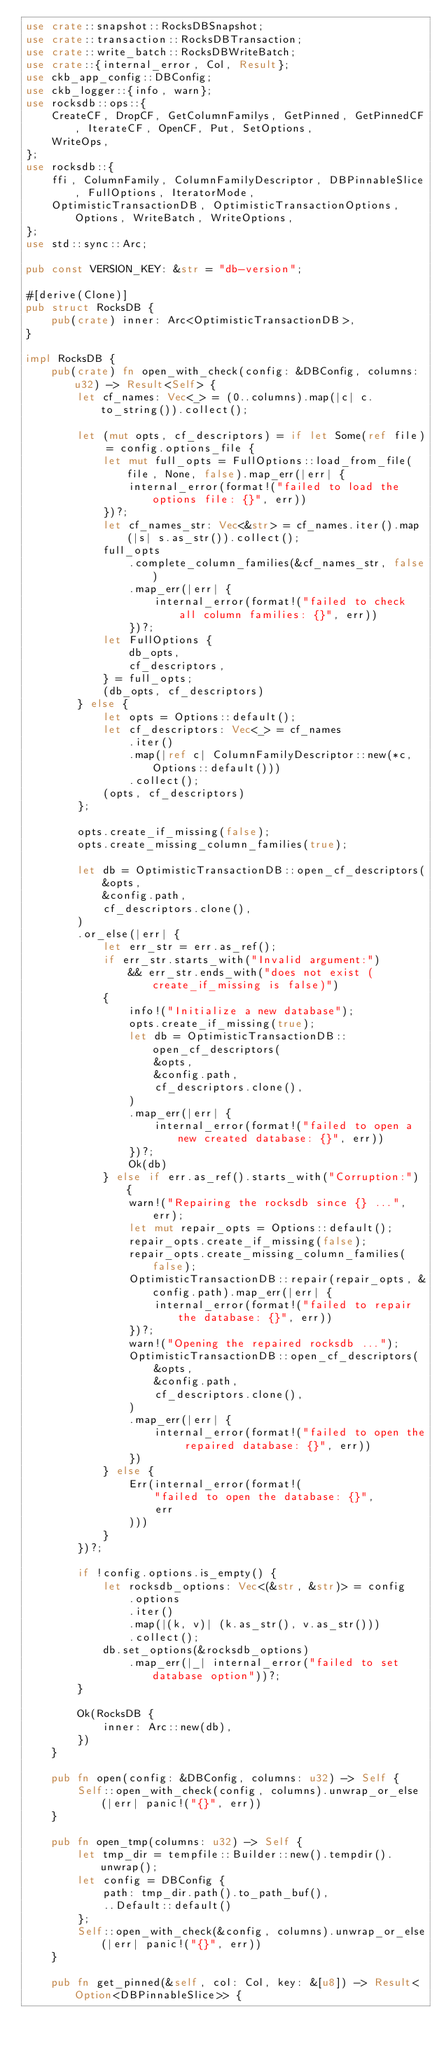<code> <loc_0><loc_0><loc_500><loc_500><_Rust_>use crate::snapshot::RocksDBSnapshot;
use crate::transaction::RocksDBTransaction;
use crate::write_batch::RocksDBWriteBatch;
use crate::{internal_error, Col, Result};
use ckb_app_config::DBConfig;
use ckb_logger::{info, warn};
use rocksdb::ops::{
    CreateCF, DropCF, GetColumnFamilys, GetPinned, GetPinnedCF, IterateCF, OpenCF, Put, SetOptions,
    WriteOps,
};
use rocksdb::{
    ffi, ColumnFamily, ColumnFamilyDescriptor, DBPinnableSlice, FullOptions, IteratorMode,
    OptimisticTransactionDB, OptimisticTransactionOptions, Options, WriteBatch, WriteOptions,
};
use std::sync::Arc;

pub const VERSION_KEY: &str = "db-version";

#[derive(Clone)]
pub struct RocksDB {
    pub(crate) inner: Arc<OptimisticTransactionDB>,
}

impl RocksDB {
    pub(crate) fn open_with_check(config: &DBConfig, columns: u32) -> Result<Self> {
        let cf_names: Vec<_> = (0..columns).map(|c| c.to_string()).collect();

        let (mut opts, cf_descriptors) = if let Some(ref file) = config.options_file {
            let mut full_opts = FullOptions::load_from_file(file, None, false).map_err(|err| {
                internal_error(format!("failed to load the options file: {}", err))
            })?;
            let cf_names_str: Vec<&str> = cf_names.iter().map(|s| s.as_str()).collect();
            full_opts
                .complete_column_families(&cf_names_str, false)
                .map_err(|err| {
                    internal_error(format!("failed to check all column families: {}", err))
                })?;
            let FullOptions {
                db_opts,
                cf_descriptors,
            } = full_opts;
            (db_opts, cf_descriptors)
        } else {
            let opts = Options::default();
            let cf_descriptors: Vec<_> = cf_names
                .iter()
                .map(|ref c| ColumnFamilyDescriptor::new(*c, Options::default()))
                .collect();
            (opts, cf_descriptors)
        };

        opts.create_if_missing(false);
        opts.create_missing_column_families(true);

        let db = OptimisticTransactionDB::open_cf_descriptors(
            &opts,
            &config.path,
            cf_descriptors.clone(),
        )
        .or_else(|err| {
            let err_str = err.as_ref();
            if err_str.starts_with("Invalid argument:")
                && err_str.ends_with("does not exist (create_if_missing is false)")
            {
                info!("Initialize a new database");
                opts.create_if_missing(true);
                let db = OptimisticTransactionDB::open_cf_descriptors(
                    &opts,
                    &config.path,
                    cf_descriptors.clone(),
                )
                .map_err(|err| {
                    internal_error(format!("failed to open a new created database: {}", err))
                })?;
                Ok(db)
            } else if err.as_ref().starts_with("Corruption:") {
                warn!("Repairing the rocksdb since {} ...", err);
                let mut repair_opts = Options::default();
                repair_opts.create_if_missing(false);
                repair_opts.create_missing_column_families(false);
                OptimisticTransactionDB::repair(repair_opts, &config.path).map_err(|err| {
                    internal_error(format!("failed to repair the database: {}", err))
                })?;
                warn!("Opening the repaired rocksdb ...");
                OptimisticTransactionDB::open_cf_descriptors(
                    &opts,
                    &config.path,
                    cf_descriptors.clone(),
                )
                .map_err(|err| {
                    internal_error(format!("failed to open the repaired database: {}", err))
                })
            } else {
                Err(internal_error(format!(
                    "failed to open the database: {}",
                    err
                )))
            }
        })?;

        if !config.options.is_empty() {
            let rocksdb_options: Vec<(&str, &str)> = config
                .options
                .iter()
                .map(|(k, v)| (k.as_str(), v.as_str()))
                .collect();
            db.set_options(&rocksdb_options)
                .map_err(|_| internal_error("failed to set database option"))?;
        }

        Ok(RocksDB {
            inner: Arc::new(db),
        })
    }

    pub fn open(config: &DBConfig, columns: u32) -> Self {
        Self::open_with_check(config, columns).unwrap_or_else(|err| panic!("{}", err))
    }

    pub fn open_tmp(columns: u32) -> Self {
        let tmp_dir = tempfile::Builder::new().tempdir().unwrap();
        let config = DBConfig {
            path: tmp_dir.path().to_path_buf(),
            ..Default::default()
        };
        Self::open_with_check(&config, columns).unwrap_or_else(|err| panic!("{}", err))
    }

    pub fn get_pinned(&self, col: Col, key: &[u8]) -> Result<Option<DBPinnableSlice>> {</code> 